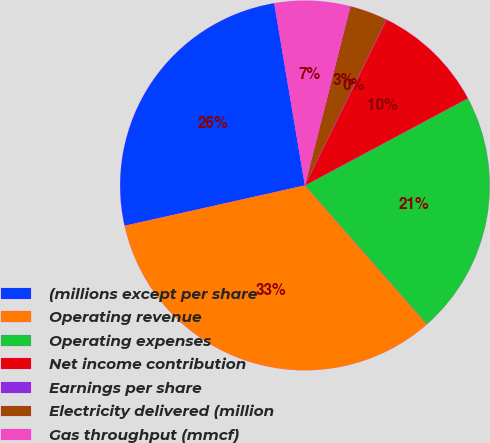<chart> <loc_0><loc_0><loc_500><loc_500><pie_chart><fcel>(millions except per share<fcel>Operating revenue<fcel>Operating expenses<fcel>Net income contribution<fcel>Earnings per share<fcel>Electricity delivered (million<fcel>Gas throughput (mmcf)<nl><fcel>25.85%<fcel>32.96%<fcel>21.35%<fcel>9.9%<fcel>0.02%<fcel>3.31%<fcel>6.61%<nl></chart> 